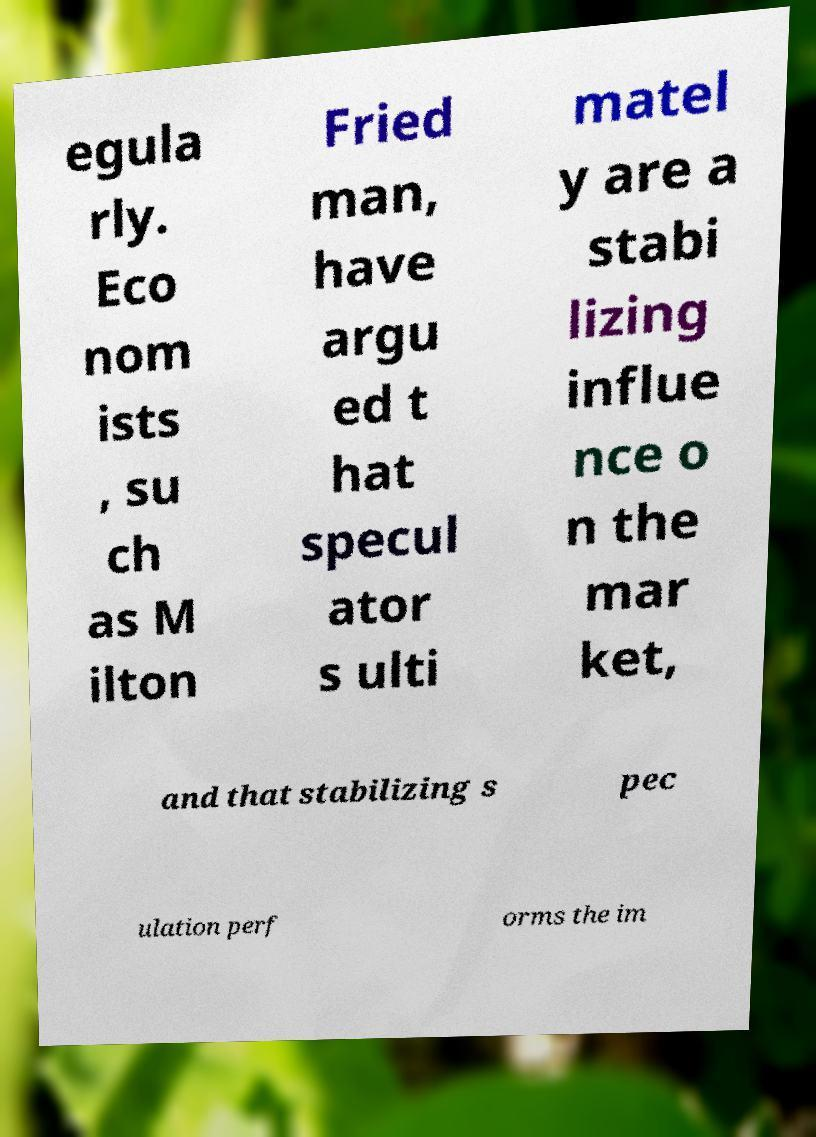Please read and relay the text visible in this image. What does it say? egula rly. Eco nom ists , su ch as M ilton Fried man, have argu ed t hat specul ator s ulti matel y are a stabi lizing influe nce o n the mar ket, and that stabilizing s pec ulation perf orms the im 